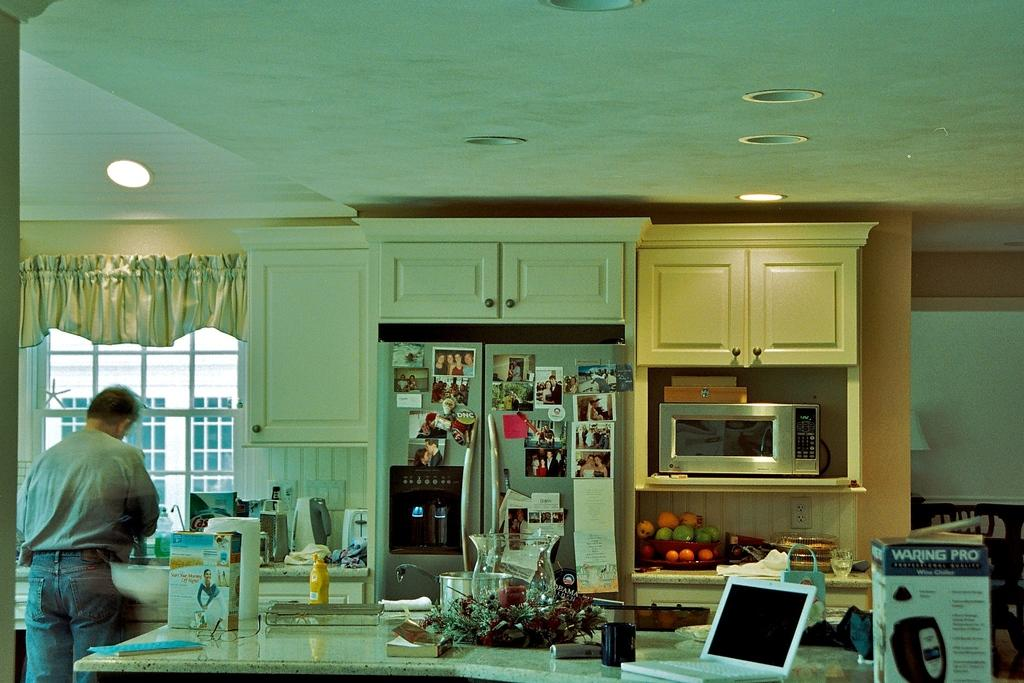<image>
Write a terse but informative summary of the picture. a kitchen with a countertop filled with boxing including Waring PRO 